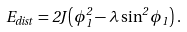<formula> <loc_0><loc_0><loc_500><loc_500>E _ { d i s t } = 2 J \left ( \phi _ { 1 } ^ { 2 } - \lambda \sin ^ { 2 } \phi _ { 1 } \right ) \, .</formula> 